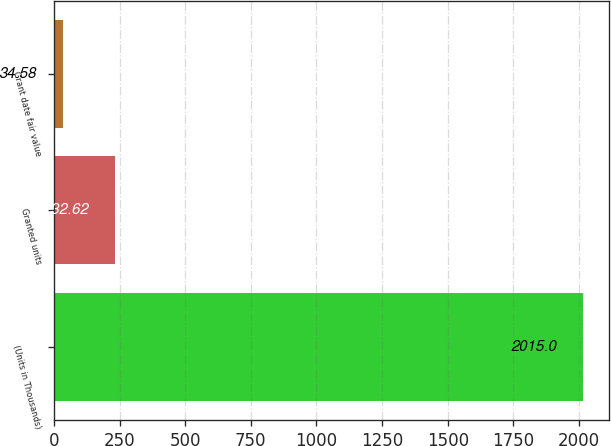Convert chart to OTSL. <chart><loc_0><loc_0><loc_500><loc_500><bar_chart><fcel>(Units in Thousands)<fcel>Granted units<fcel>Grant date fair value<nl><fcel>2015<fcel>232.62<fcel>34.58<nl></chart> 